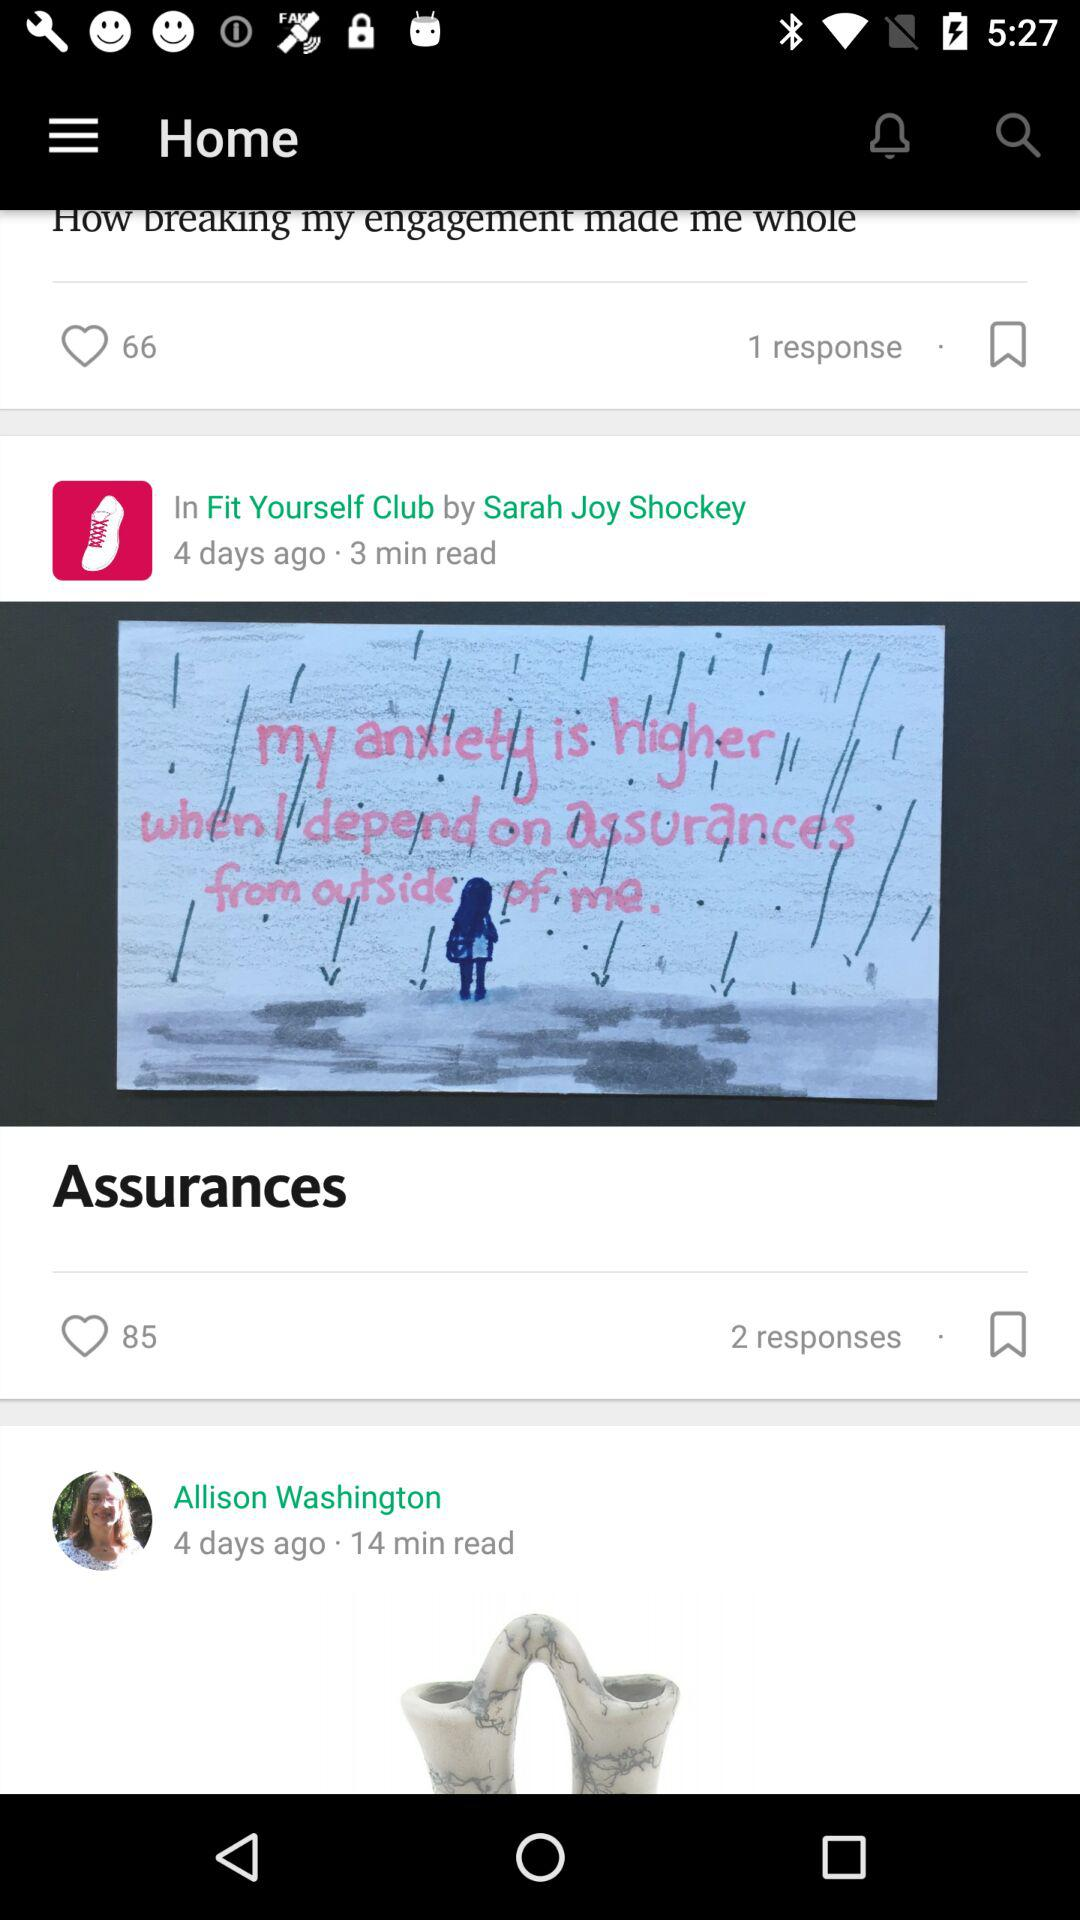What mood does the artwork in the 'Assurances' article evoke? The artwork in the 'Assurances' article portrays a somber and reflective mood. The image of a solitary figure amidst a backdrop of dreary weather and the text about anxiety suggests a theme of introspection and the struggle to find inner peace. 